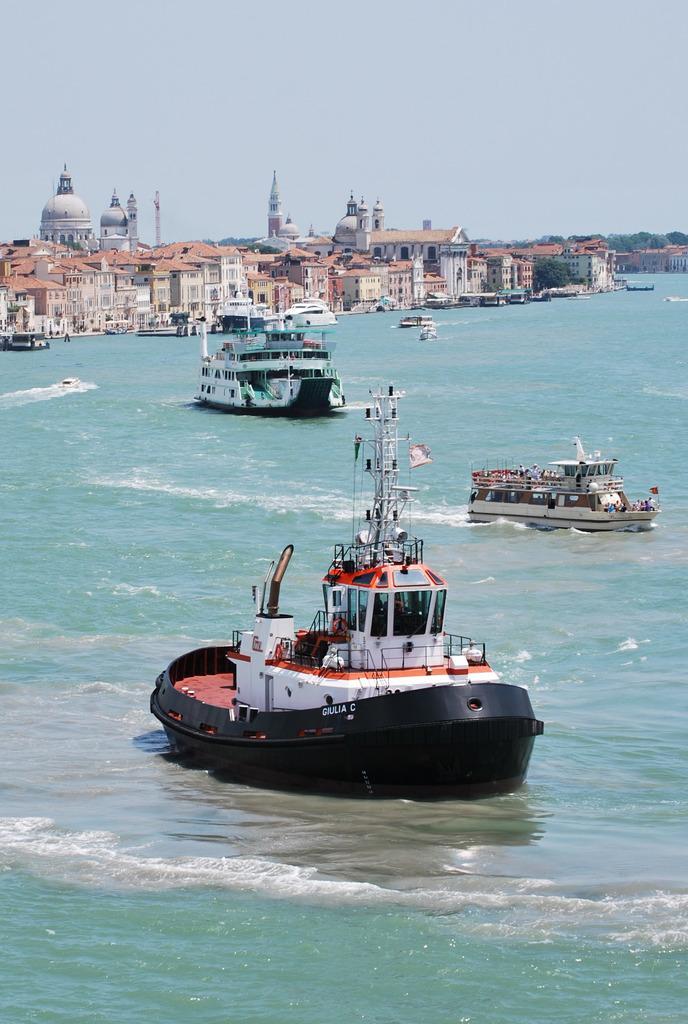In one or two sentences, can you explain what this image depicts? In this image we can see many buildings. There are few ships which are sailing on the sea. There are many trees in the image. 